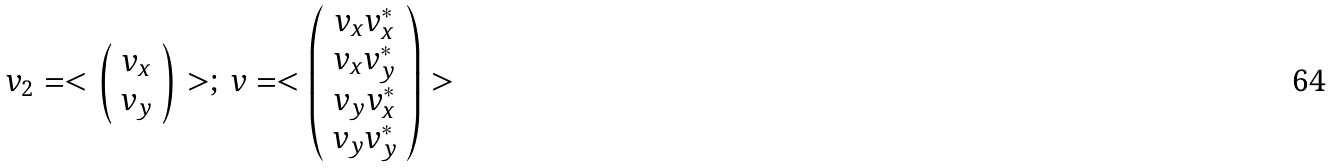<formula> <loc_0><loc_0><loc_500><loc_500>v _ { 2 } = < \left ( \begin{array} { c } v _ { x } \\ v _ { y } \end{array} \right ) > ; \, v = < \left ( \begin{array} { c } v _ { x } v _ { x } ^ { * } \\ v _ { x } v _ { y } ^ { * } \\ v _ { y } v _ { x } ^ { * } \\ v _ { y } v _ { y } ^ { * } \end{array} \right ) ></formula> 